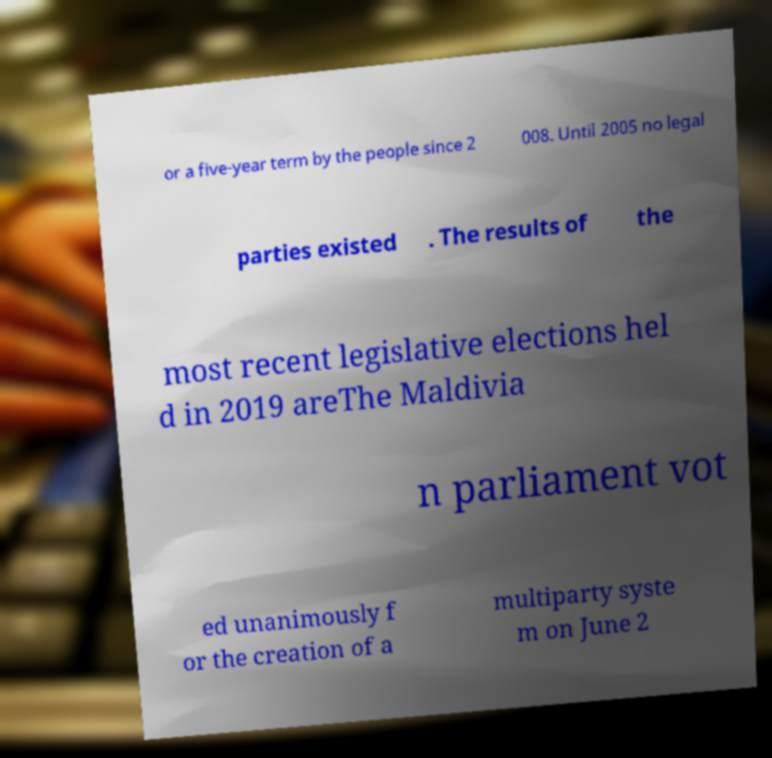Please read and relay the text visible in this image. What does it say? or a five-year term by the people since 2 008. Until 2005 no legal parties existed . The results of the most recent legislative elections hel d in 2019 areThe Maldivia n parliament vot ed unanimously f or the creation of a multiparty syste m on June 2 